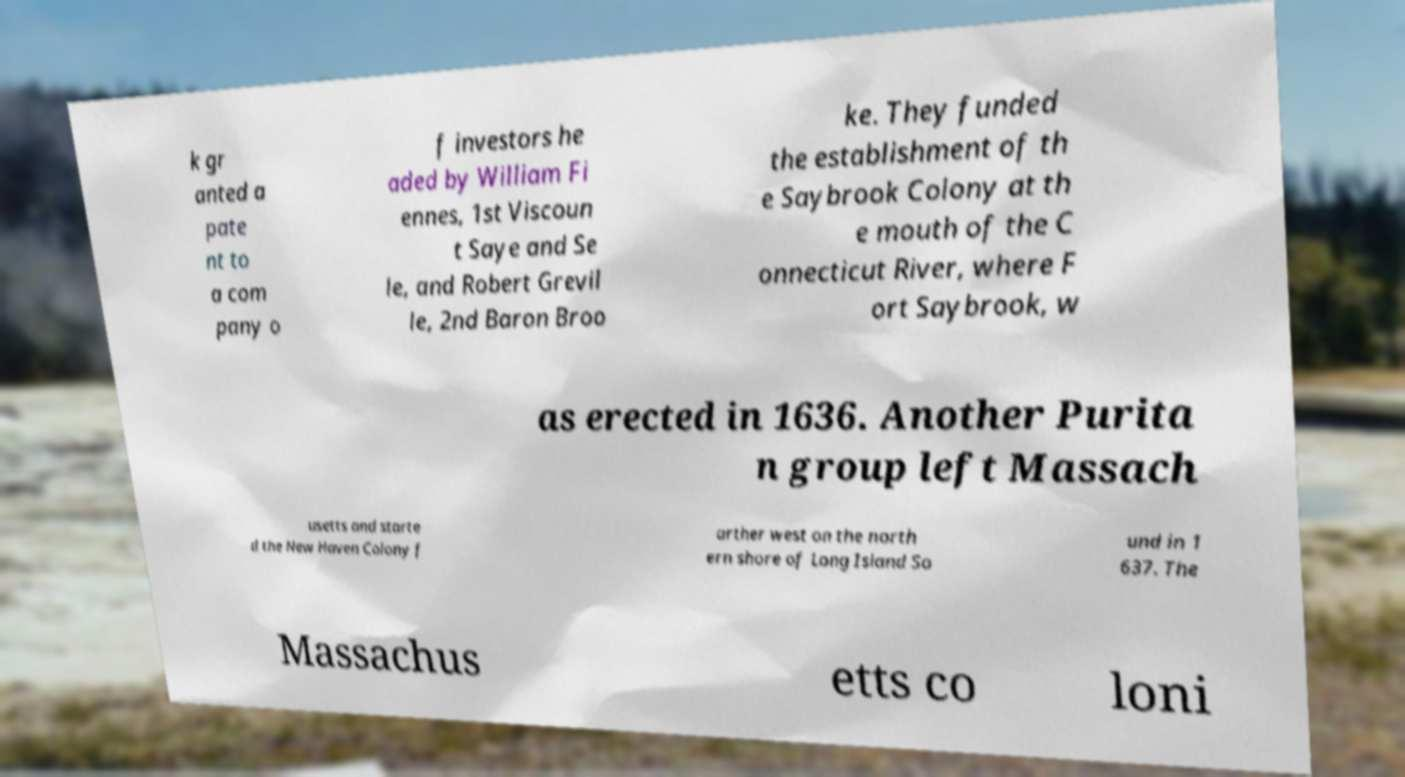What messages or text are displayed in this image? I need them in a readable, typed format. k gr anted a pate nt to a com pany o f investors he aded by William Fi ennes, 1st Viscoun t Saye and Se le, and Robert Grevil le, 2nd Baron Broo ke. They funded the establishment of th e Saybrook Colony at th e mouth of the C onnecticut River, where F ort Saybrook, w as erected in 1636. Another Purita n group left Massach usetts and starte d the New Haven Colony f arther west on the north ern shore of Long Island So und in 1 637. The Massachus etts co loni 